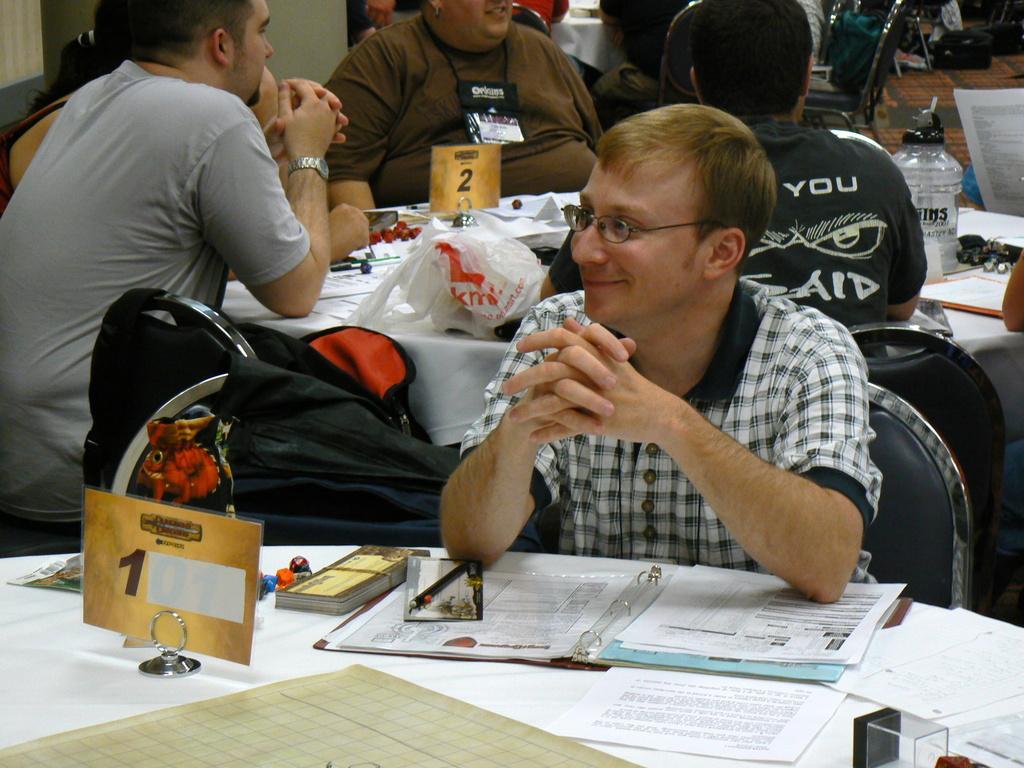Describe this image in one or two sentences. Here I can see a man wearing a shirt, sitting on the chair and smiling by looking at the left side. In front of this man there is a table which is covered with a white color cloth. On the table, I can see few papers. At the back of this man there are some more people are sitting on the chairs around another table, that is also covered with a white colored cloth. On the table I can see a bottle, box, papers and some other objects. In the top right I can see few empty chairs on the floor. 